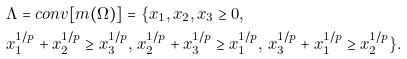Convert formula to latex. <formula><loc_0><loc_0><loc_500><loc_500>& \Lambda = c o n v [ m ( \Omega ) ] = \{ x _ { 1 } , x _ { 2 } , x _ { 3 } \geq 0 , \\ & x _ { 1 } ^ { 1 / p } + x _ { 2 } ^ { 1 / p } \geq x _ { 3 } ^ { 1 / p } , \, x _ { 2 } ^ { 1 / p } + x _ { 3 } ^ { 1 / p } \geq x _ { 1 } ^ { 1 / p } , \, x _ { 3 } ^ { 1 / p } + x _ { 1 } ^ { 1 / p } \geq x _ { 2 } ^ { 1 / p } \} .</formula> 